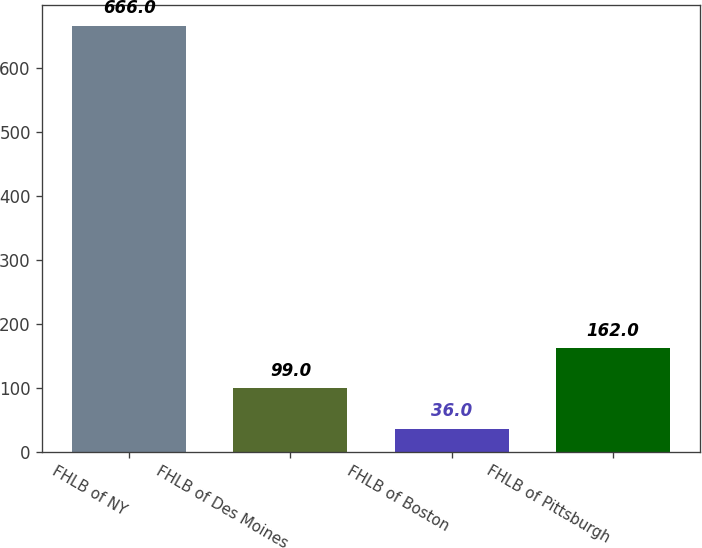Convert chart. <chart><loc_0><loc_0><loc_500><loc_500><bar_chart><fcel>FHLB of NY<fcel>FHLB of Des Moines<fcel>FHLB of Boston<fcel>FHLB of Pittsburgh<nl><fcel>666<fcel>99<fcel>36<fcel>162<nl></chart> 